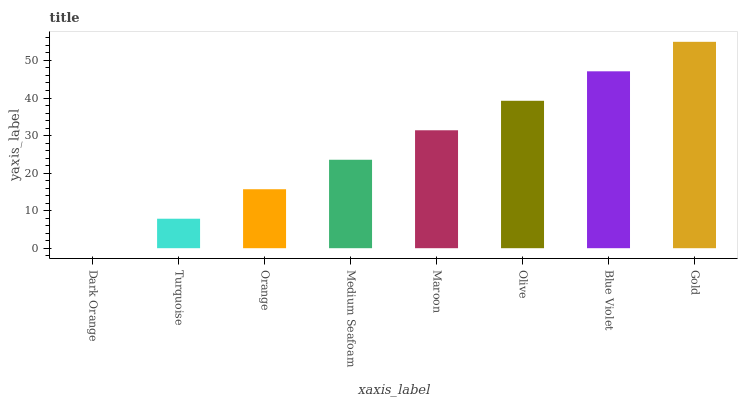Is Dark Orange the minimum?
Answer yes or no. Yes. Is Gold the maximum?
Answer yes or no. Yes. Is Turquoise the minimum?
Answer yes or no. No. Is Turquoise the maximum?
Answer yes or no. No. Is Turquoise greater than Dark Orange?
Answer yes or no. Yes. Is Dark Orange less than Turquoise?
Answer yes or no. Yes. Is Dark Orange greater than Turquoise?
Answer yes or no. No. Is Turquoise less than Dark Orange?
Answer yes or no. No. Is Maroon the high median?
Answer yes or no. Yes. Is Medium Seafoam the low median?
Answer yes or no. Yes. Is Turquoise the high median?
Answer yes or no. No. Is Maroon the low median?
Answer yes or no. No. 